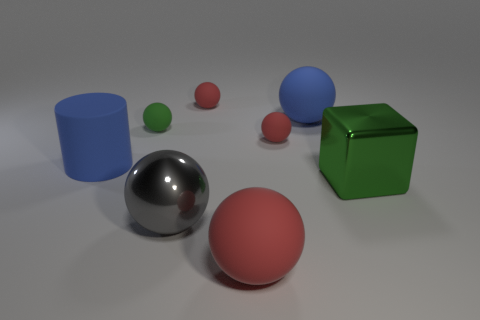What shape is the green thing behind the green metal thing?
Provide a succinct answer. Sphere. What number of brown things are matte cylinders or rubber blocks?
Your response must be concise. 0. Is the material of the blue cylinder the same as the large green object?
Offer a terse response. No. What number of big red matte things are in front of the big red rubber object?
Offer a very short reply. 0. What material is the thing that is both left of the big red rubber ball and in front of the cube?
Give a very brief answer. Metal. How many balls are big green shiny things or tiny green objects?
Provide a short and direct response. 1. There is a big red object that is the same shape as the small green thing; what material is it?
Ensure brevity in your answer.  Rubber. What size is the blue sphere that is the same material as the cylinder?
Ensure brevity in your answer.  Large. There is a small rubber thing left of the large gray metallic ball; is its shape the same as the large shiny object that is behind the gray metal ball?
Keep it short and to the point. No. The cube that is the same material as the large gray thing is what color?
Ensure brevity in your answer.  Green. 